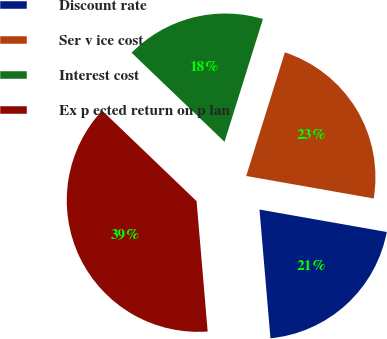Convert chart. <chart><loc_0><loc_0><loc_500><loc_500><pie_chart><fcel>Discount rate<fcel>Ser v ice cost<fcel>Interest cost<fcel>Ex p ected return on p lan<nl><fcel>20.87%<fcel>22.95%<fcel>17.66%<fcel>38.52%<nl></chart> 